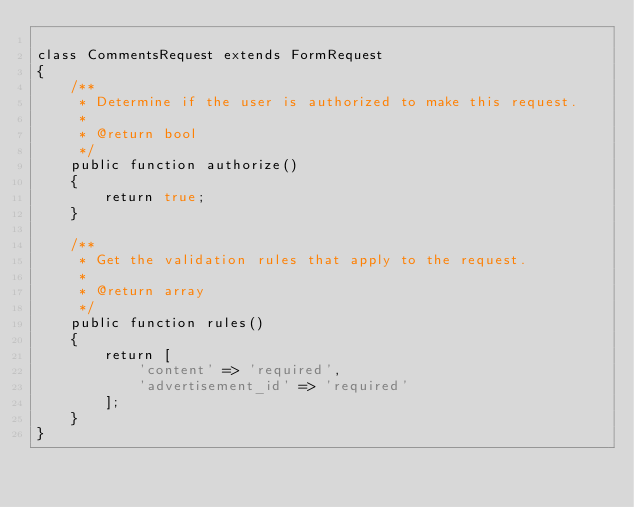<code> <loc_0><loc_0><loc_500><loc_500><_PHP_>
class CommentsRequest extends FormRequest
{
    /**
     * Determine if the user is authorized to make this request.
     *
     * @return bool
     */
    public function authorize()
    {
        return true;
    }

    /**
     * Get the validation rules that apply to the request.
     *
     * @return array
     */
    public function rules()
    {
        return [
            'content' => 'required',
            'advertisement_id' => 'required'
        ];
    }
}
</code> 